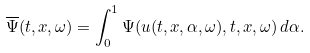<formula> <loc_0><loc_0><loc_500><loc_500>\overline { \Psi } ( t , x , \omega ) = \int _ { 0 } ^ { 1 } \Psi ( u ( t , x , \alpha , \omega ) , t , x , \omega ) \, d \alpha .</formula> 